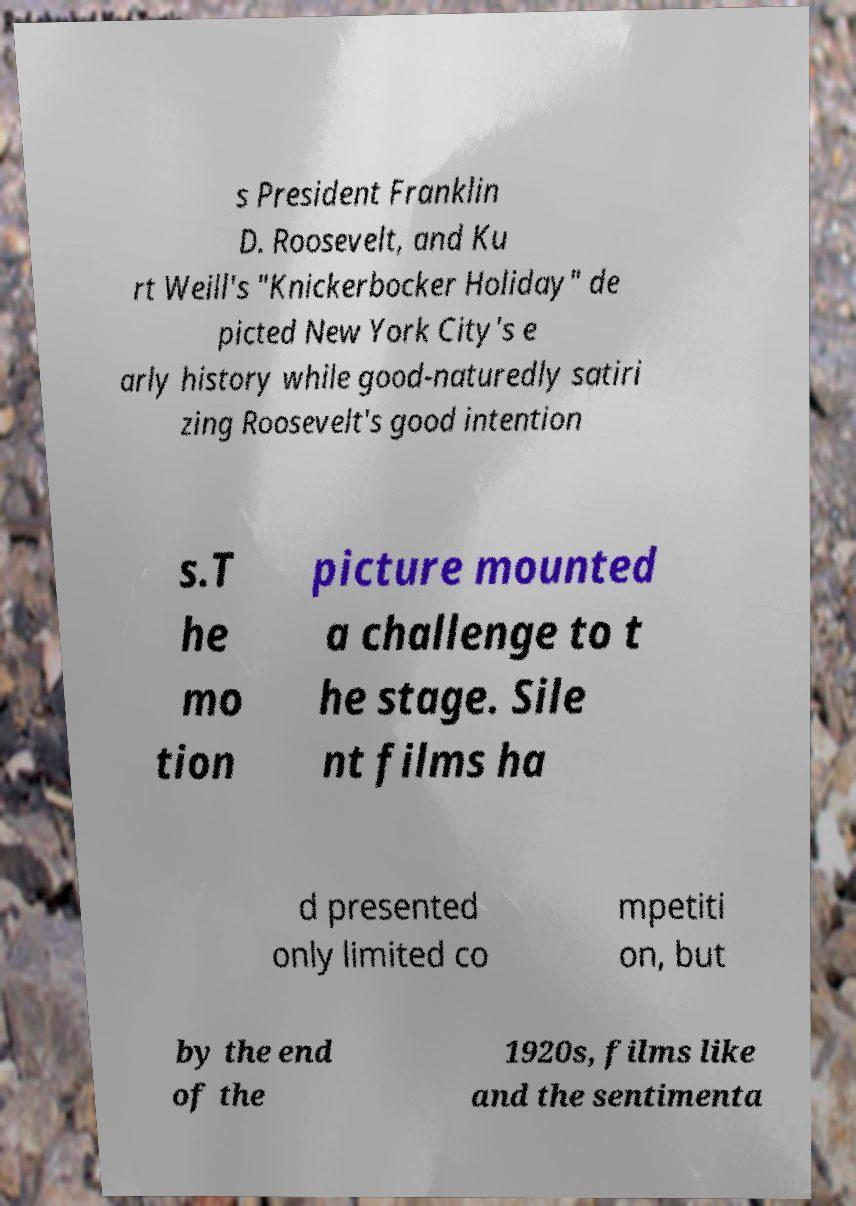There's text embedded in this image that I need extracted. Can you transcribe it verbatim? s President Franklin D. Roosevelt, and Ku rt Weill's "Knickerbocker Holiday" de picted New York City's e arly history while good-naturedly satiri zing Roosevelt's good intention s.T he mo tion picture mounted a challenge to t he stage. Sile nt films ha d presented only limited co mpetiti on, but by the end of the 1920s, films like and the sentimenta 